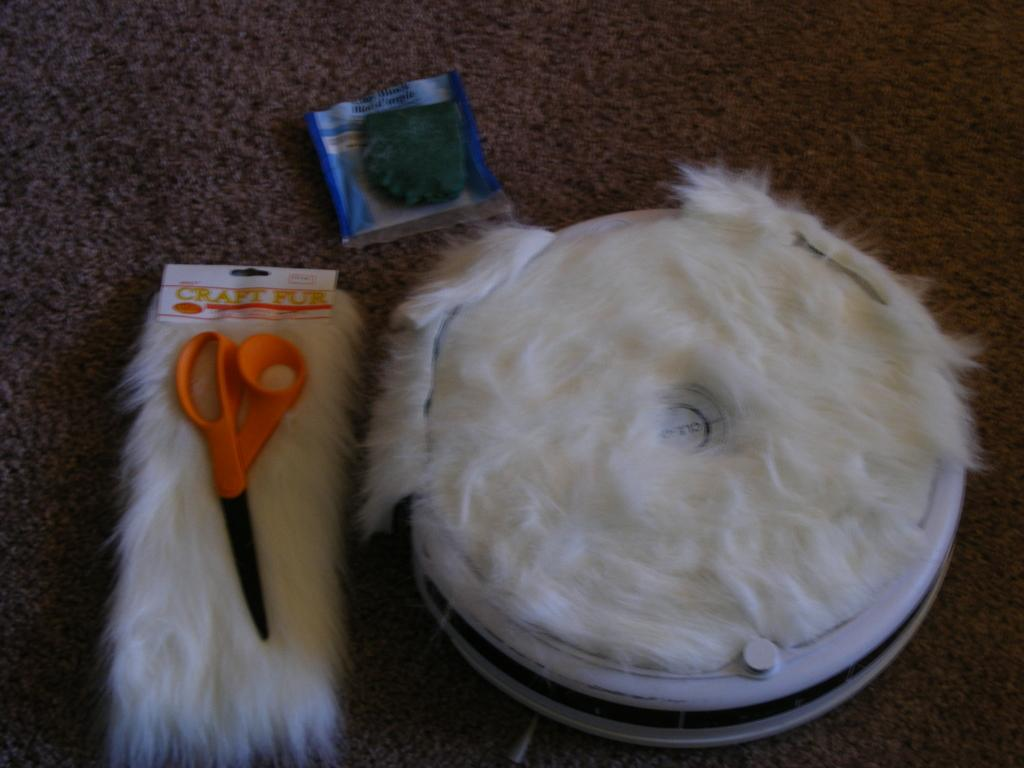What shape is the fur piece in the image? The fur piece in the image is rectangular. What tool is placed on the fur piece? There is a scissor on the fur piece. What type of object is covered with fur in the image? There is a round object covered with fur in the image. What can be seen on the floor in the image? There is a small packet on the carpet. How many teeth can be seen on the fur piece in the image? There are no teeth visible on the fur piece in the image. What type of line is present in the image? There is no line present in the image. 